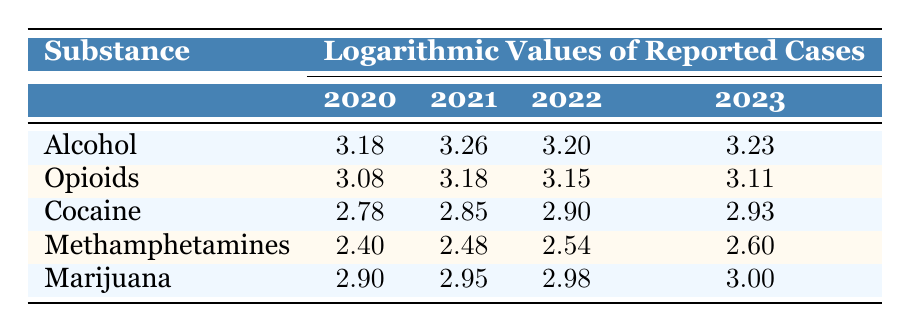What were the reported alcohol cases in 2021? The table shows the logarithmic value for alcohol cases in 2021, which is 3.26. By converting that back to the original scale using exponential function, we derive that the reported cases are approximately 1,800.
Answer: 1800 Which year had the highest logarithmic value for cocaine cases? Looking at the table, the highest logarithmic value for cocaine cases occurs in 2023, which is 2.93.
Answer: 2023 What is the difference in logarithmic values of opioid cases between 2020 and 2023? The value for opioid cases in 2020 is 3.08, and in 2023 it is 3.11. To find the difference, we subtract: 3.11 - 3.08 = 0.03.
Answer: 0.03 Was there an increase in marijuana cases from 2020 to 2023? By comparing the logarithmic values for marijuana cases, we see in 2020 it was 2.90, and in 2023, it rose to 3.00, indicating an increase. Therefore, the answer is yes.
Answer: Yes What is the average logarithmic value for methamphetamines from 2020 to 2023? To calculate the average, we sum the values for methamphetamines (2.40 + 2.48 + 2.54 + 2.60 = 10.02) and divide by the number of years (4): 10.02 / 4 = 2.505.
Answer: 2.505 What was the overall trend in alcohol cases reported from 2020 to 2022? The values for alcohol cases are 3.18 in 2020, 3.26 in 2021, and 3.20 in 2022. Although there is an increase from 2020 to 2021, there is a slight decrease from 2021 to 2022. Thus, the overall trend shows an increase followed by a minor decrease.
Answer: Increase then decrease Which substance showed the most consistent growth in cases throughout the years? By examining the logarithmic values, alcohol generally increased each year except for a minor dip in 2022 where it dropped slightly from 3.26 back to 3.20. This shows it continues to maintain a high trend. Other substances fluctuated more.
Answer: Alcohol Was there a decrease in cocaine cases in 2022 compared to 2021? The logarithmic value for cocaine in 2021 is 2.85 and in 2022 it is 2.90. Since 2.90 is greater than 2.85, this indicates that there was actually an increase in cocaine cases in 2022 compared to 2021.
Answer: No 